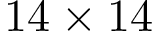<formula> <loc_0><loc_0><loc_500><loc_500>1 4 \times 1 4</formula> 